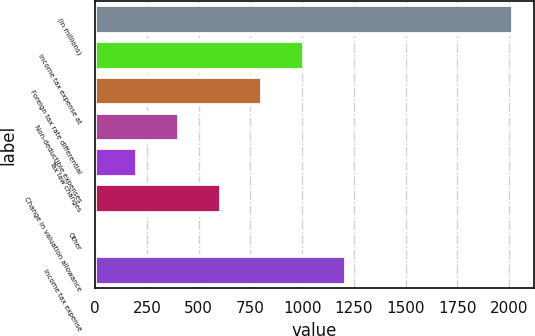Convert chart. <chart><loc_0><loc_0><loc_500><loc_500><bar_chart><fcel>(in millions)<fcel>Income tax expense at<fcel>Foreign tax rate differential<fcel>Non-deductible expenses<fcel>Tax law changes<fcel>Change in valuation allowance<fcel>Other<fcel>Income tax expense<nl><fcel>2019<fcel>1009.6<fcel>807.72<fcel>403.96<fcel>202.08<fcel>605.84<fcel>0.2<fcel>1211.48<nl></chart> 